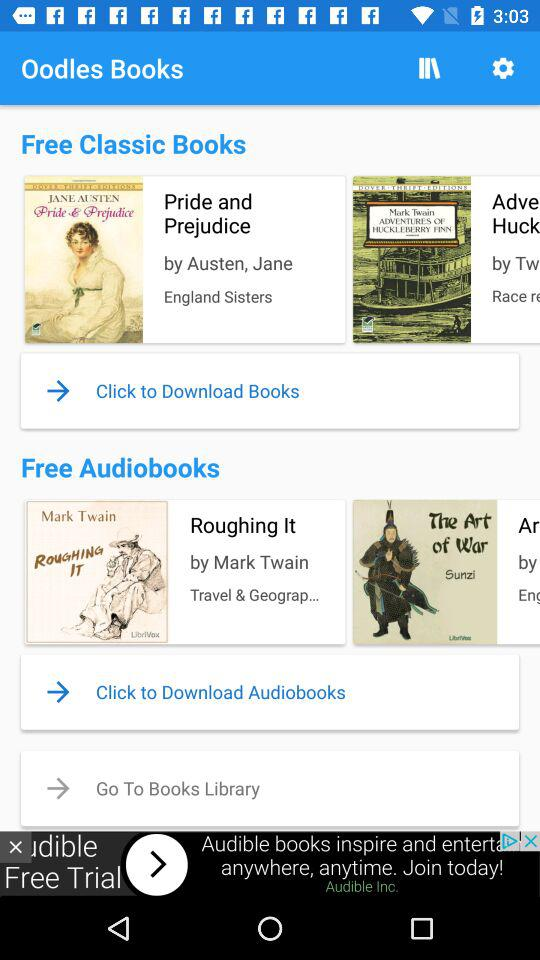Who is the author of the book "Roughing It"? The author of the book "Roughing It" is Mark Twain. 